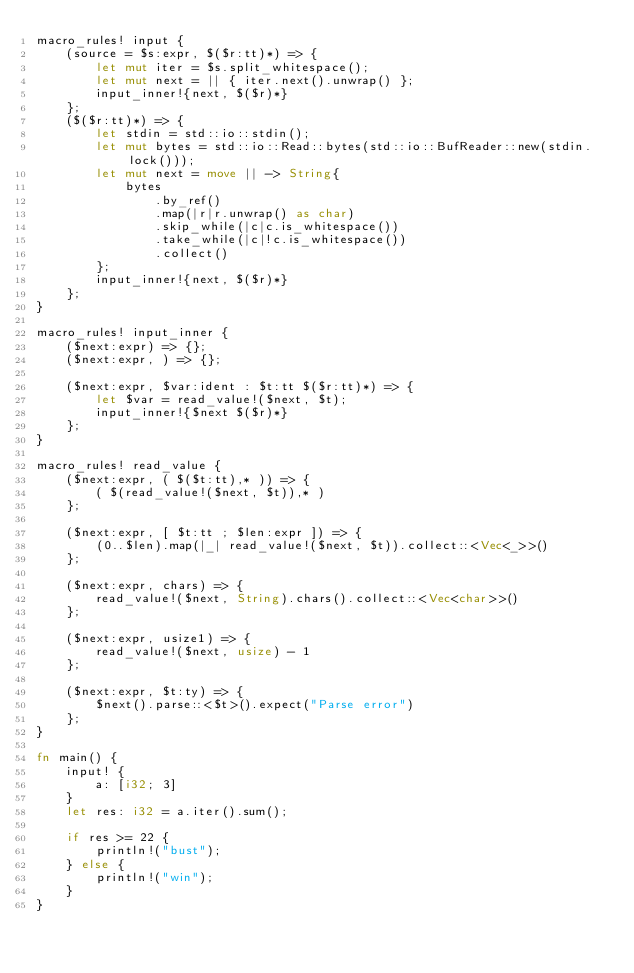<code> <loc_0><loc_0><loc_500><loc_500><_Rust_>macro_rules! input {
    (source = $s:expr, $($r:tt)*) => {
        let mut iter = $s.split_whitespace();
        let mut next = || { iter.next().unwrap() };
        input_inner!{next, $($r)*}
    };
    ($($r:tt)*) => {
        let stdin = std::io::stdin();
        let mut bytes = std::io::Read::bytes(std::io::BufReader::new(stdin.lock()));
        let mut next = move || -> String{
            bytes
                .by_ref()
                .map(|r|r.unwrap() as char)
                .skip_while(|c|c.is_whitespace())
                .take_while(|c|!c.is_whitespace())
                .collect()
        };
        input_inner!{next, $($r)*}
    };
}

macro_rules! input_inner {
    ($next:expr) => {};
    ($next:expr, ) => {};

    ($next:expr, $var:ident : $t:tt $($r:tt)*) => {
        let $var = read_value!($next, $t);
        input_inner!{$next $($r)*}
    };
}

macro_rules! read_value {
    ($next:expr, ( $($t:tt),* )) => {
        ( $(read_value!($next, $t)),* )
    };

    ($next:expr, [ $t:tt ; $len:expr ]) => {
        (0..$len).map(|_| read_value!($next, $t)).collect::<Vec<_>>()
    };

    ($next:expr, chars) => {
        read_value!($next, String).chars().collect::<Vec<char>>()
    };

    ($next:expr, usize1) => {
        read_value!($next, usize) - 1
    };

    ($next:expr, $t:ty) => {
        $next().parse::<$t>().expect("Parse error")
    };
}

fn main() {
    input! {
        a: [i32; 3]
    }
    let res: i32 = a.iter().sum();

    if res >= 22 {
        println!("bust");
    } else {
        println!("win");
    }
}
</code> 